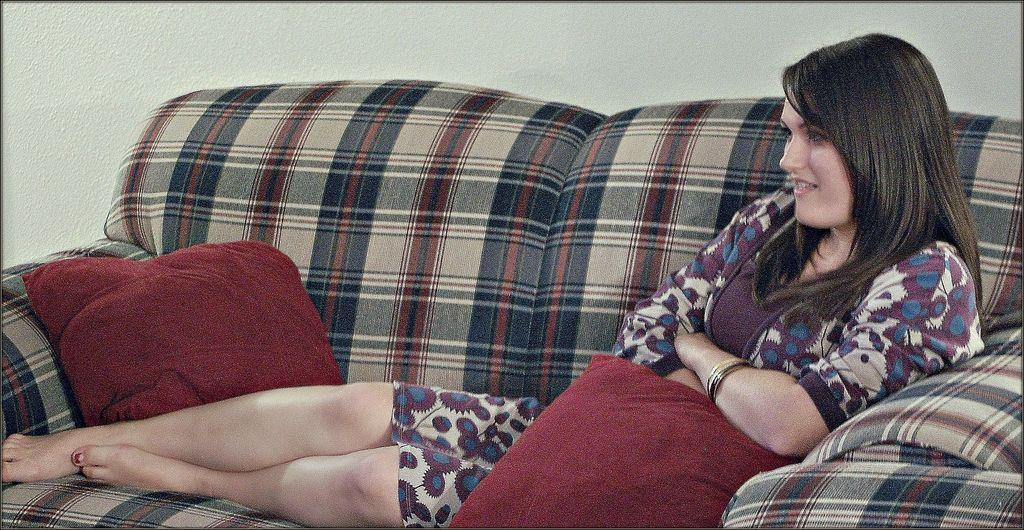Who is present in the image? There is a woman in the image. What is the woman doing in the image? The woman is sitting on a sofa. What color are the cushions on the sofa? The cushions on the sofa are red-colored. What can be seen in the background of the image? There is a wall in the background of the image. What type of hat is the woman wearing in the image? The woman is not wearing a hat in the image. What industry is depicted in the image? There is no specific industry depicted in the image; it features a woman sitting on a sofa with red-colored cushions and a wall in the background. 